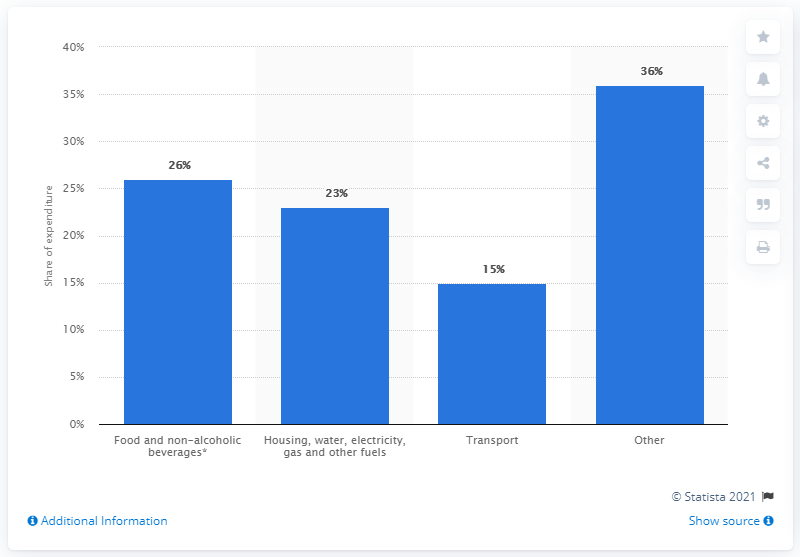Mention a couple of crucial points in this snapshot. In 2016, households spent approximately 26% of their income on food and non-alcoholic beverages. 